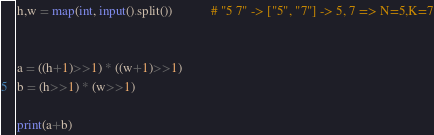Convert code to text. <code><loc_0><loc_0><loc_500><loc_500><_Python_>h,w = map(int, input().split())			# "5 7" -> ["5", "7"] -> 5, 7 => N=5,K=7


a = ((h+1)>>1) * ((w+1)>>1)
b = (h>>1) * (w>>1)

print(a+b)



</code> 